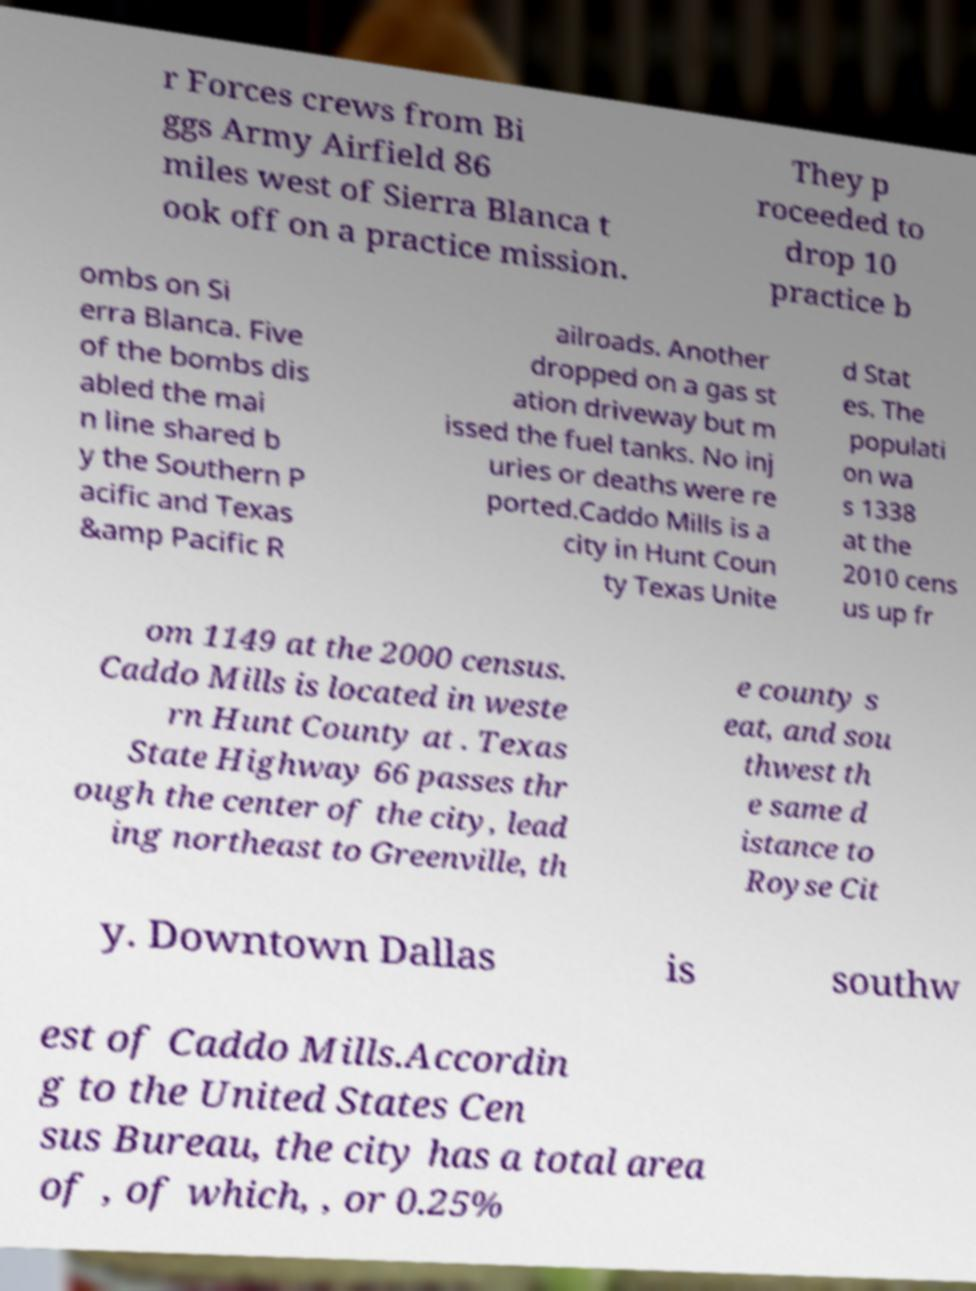Please read and relay the text visible in this image. What does it say? r Forces crews from Bi ggs Army Airfield 86 miles west of Sierra Blanca t ook off on a practice mission. They p roceeded to drop 10 practice b ombs on Si erra Blanca. Five of the bombs dis abled the mai n line shared b y the Southern P acific and Texas &amp Pacific R ailroads. Another dropped on a gas st ation driveway but m issed the fuel tanks. No inj uries or deaths were re ported.Caddo Mills is a city in Hunt Coun ty Texas Unite d Stat es. The populati on wa s 1338 at the 2010 cens us up fr om 1149 at the 2000 census. Caddo Mills is located in weste rn Hunt County at . Texas State Highway 66 passes thr ough the center of the city, lead ing northeast to Greenville, th e county s eat, and sou thwest th e same d istance to Royse Cit y. Downtown Dallas is southw est of Caddo Mills.Accordin g to the United States Cen sus Bureau, the city has a total area of , of which, , or 0.25% 